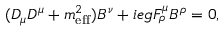Convert formula to latex. <formula><loc_0><loc_0><loc_500><loc_500>( D _ { \mu } D ^ { \mu } + m _ { e f f } ^ { 2 } ) B ^ { \nu } + i e g F _ { \rho } ^ { \mu } B ^ { \rho } = 0 ,</formula> 